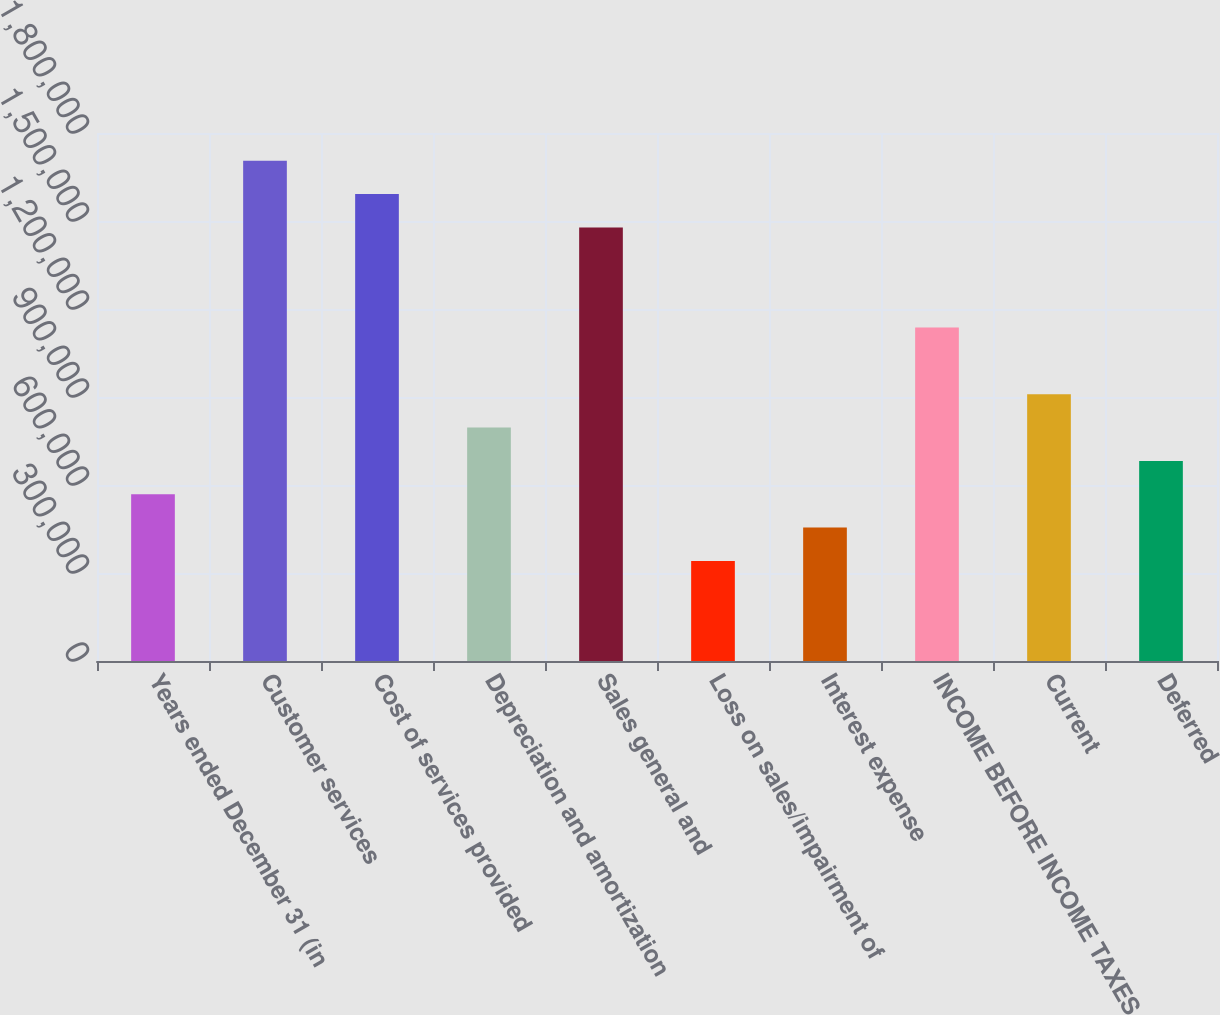Convert chart to OTSL. <chart><loc_0><loc_0><loc_500><loc_500><bar_chart><fcel>Years ended December 31 (in<fcel>Customer services<fcel>Cost of services provided<fcel>Depreciation and amortization<fcel>Sales general and<fcel>Loss on sales/impairment of<fcel>Interest expense<fcel>INCOME BEFORE INCOME TAXES<fcel>Current<fcel>Deferred<nl><fcel>568445<fcel>1.70533e+06<fcel>1.59165e+06<fcel>795823<fcel>1.47796e+06<fcel>341067<fcel>454756<fcel>1.13689e+06<fcel>909512<fcel>682134<nl></chart> 